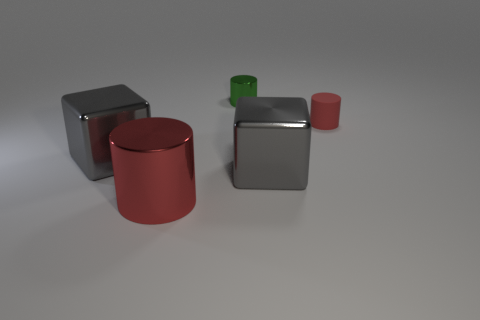Subtract all red cubes. How many red cylinders are left? 2 Subtract 1 cylinders. How many cylinders are left? 2 Subtract all small cylinders. How many cylinders are left? 1 Add 3 purple rubber things. How many objects exist? 8 Subtract all blocks. How many objects are left? 3 Subtract 0 yellow blocks. How many objects are left? 5 Subtract all tiny yellow objects. Subtract all rubber cylinders. How many objects are left? 4 Add 1 gray things. How many gray things are left? 3 Add 1 large metal cubes. How many large metal cubes exist? 3 